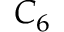Convert formula to latex. <formula><loc_0><loc_0><loc_500><loc_500>C _ { 6 }</formula> 